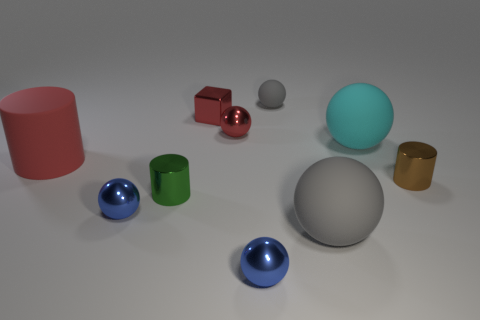There is another metal object that is the same shape as the brown object; what color is it?
Offer a terse response. Green. Is the matte cylinder the same size as the cyan matte thing?
Give a very brief answer. Yes. How many other things are the same size as the green cylinder?
Keep it short and to the point. 6. How many objects are small objects that are right of the large cyan ball or red things that are on the right side of the red cylinder?
Ensure brevity in your answer.  3. The red thing that is the same size as the red shiny cube is what shape?
Your answer should be compact. Sphere. What size is the brown cylinder that is the same material as the red cube?
Ensure brevity in your answer.  Small. Do the red matte thing and the tiny brown thing have the same shape?
Your answer should be compact. Yes. The metal block that is the same size as the green metal cylinder is what color?
Your response must be concise. Red. There is a cyan matte thing that is the same shape as the large gray object; what is its size?
Offer a terse response. Large. There is a gray rubber object behind the big red cylinder; what shape is it?
Make the answer very short. Sphere. 